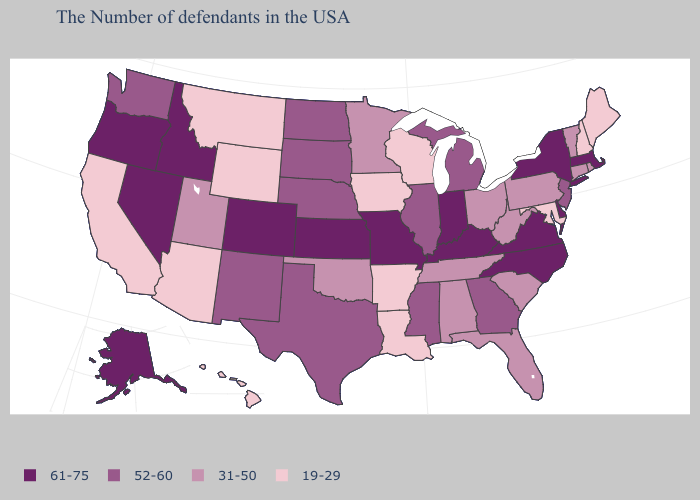Name the states that have a value in the range 19-29?
Write a very short answer. Maine, New Hampshire, Maryland, Wisconsin, Louisiana, Arkansas, Iowa, Wyoming, Montana, Arizona, California, Hawaii. Does the map have missing data?
Concise answer only. No. Does Montana have the lowest value in the West?
Answer briefly. Yes. Which states have the lowest value in the USA?
Give a very brief answer. Maine, New Hampshire, Maryland, Wisconsin, Louisiana, Arkansas, Iowa, Wyoming, Montana, Arizona, California, Hawaii. What is the lowest value in states that border Missouri?
Answer briefly. 19-29. Name the states that have a value in the range 61-75?
Be succinct. Massachusetts, New York, Delaware, Virginia, North Carolina, Kentucky, Indiana, Missouri, Kansas, Colorado, Idaho, Nevada, Oregon, Alaska. What is the lowest value in the USA?
Write a very short answer. 19-29. What is the value of Iowa?
Be succinct. 19-29. Does Oklahoma have the highest value in the USA?
Short answer required. No. Does Vermont have the same value as Ohio?
Short answer required. Yes. Name the states that have a value in the range 31-50?
Answer briefly. Rhode Island, Vermont, Connecticut, Pennsylvania, South Carolina, West Virginia, Ohio, Florida, Alabama, Tennessee, Minnesota, Oklahoma, Utah. Does the map have missing data?
Be succinct. No. Is the legend a continuous bar?
Be succinct. No. Is the legend a continuous bar?
Answer briefly. No. Among the states that border Connecticut , which have the highest value?
Write a very short answer. Massachusetts, New York. 